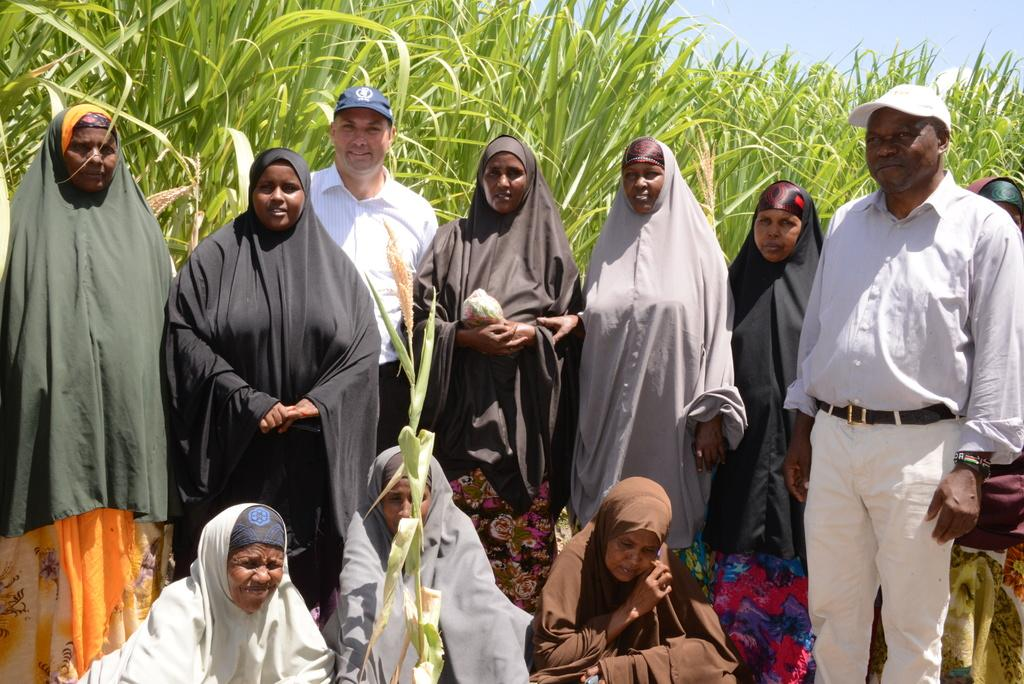How many people are in the image? There is a group of people in the image, but the exact number is not specified. What are the people in the image doing? Some people are sitting, while others are standing. What can be seen in the background of the image? There is green grass and the sky visible in the background of the image. What is the color of the sky in the image? The sky appears to be white in color. Can you tell me what statement the person with the longest nose in the image is making? There is no information about the length of anyone's nose in the image, nor is there any dialogue or statements mentioned. 